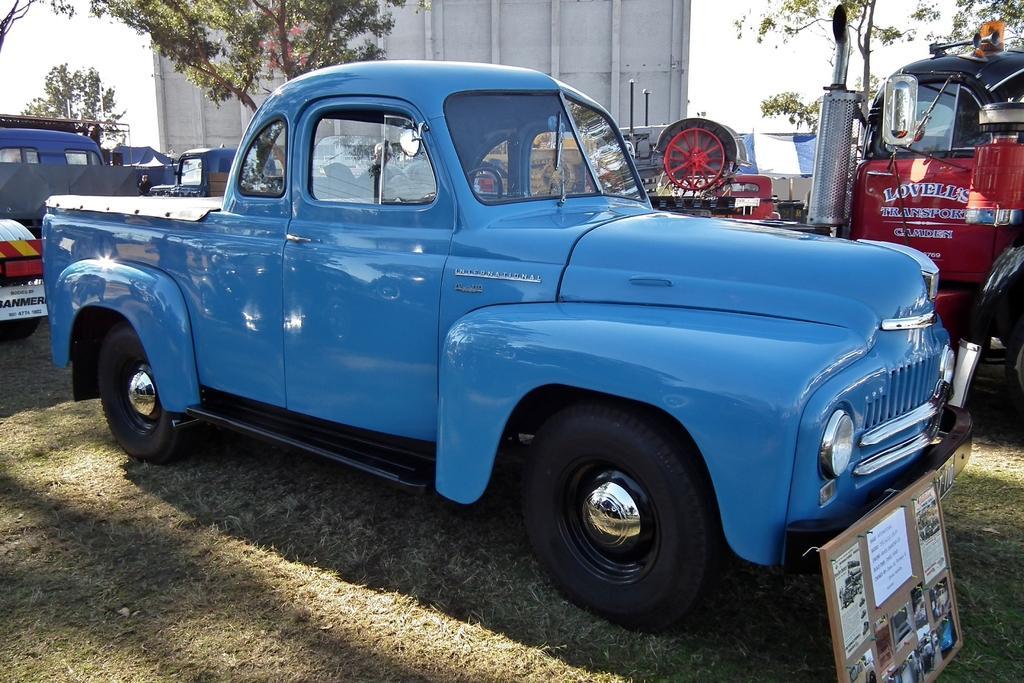Can you describe this image briefly? In this image I can see vehicles on the grass, there is a board on the right. There are trees and a wall at the back. There is sky at the top. 